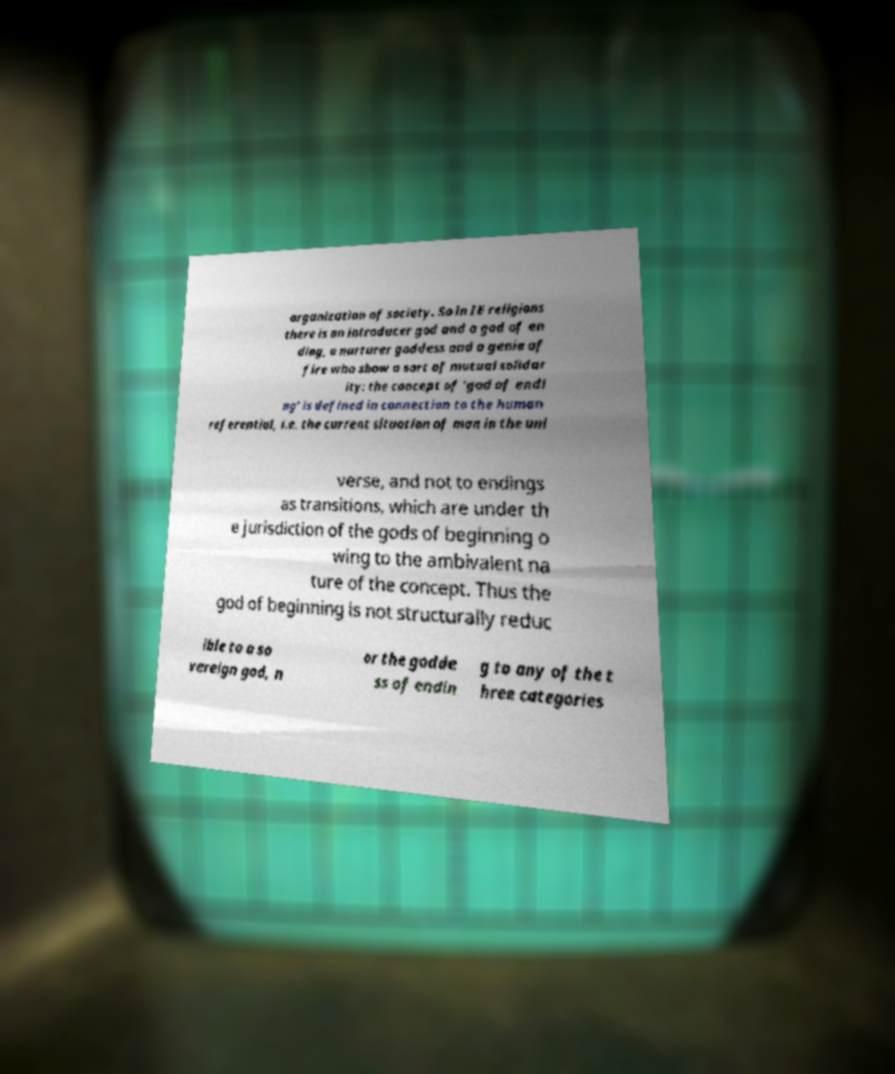Please read and relay the text visible in this image. What does it say? organization of society. So in IE religions there is an introducer god and a god of en ding, a nurturer goddess and a genie of fire who show a sort of mutual solidar ity: the concept of 'god of endi ng' is defined in connection to the human referential, i.e. the current situation of man in the uni verse, and not to endings as transitions, which are under th e jurisdiction of the gods of beginning o wing to the ambivalent na ture of the concept. Thus the god of beginning is not structurally reduc ible to a so vereign god, n or the godde ss of endin g to any of the t hree categories 